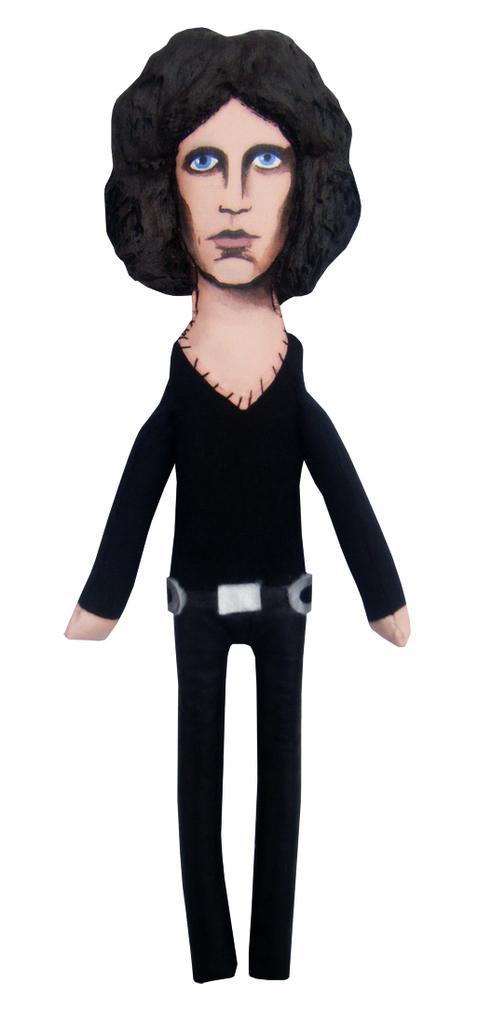Describe this image in one or two sentences. In this picture I can see there is a man standing here and is wearing a black shirt and pant. There is a white backdrop. 